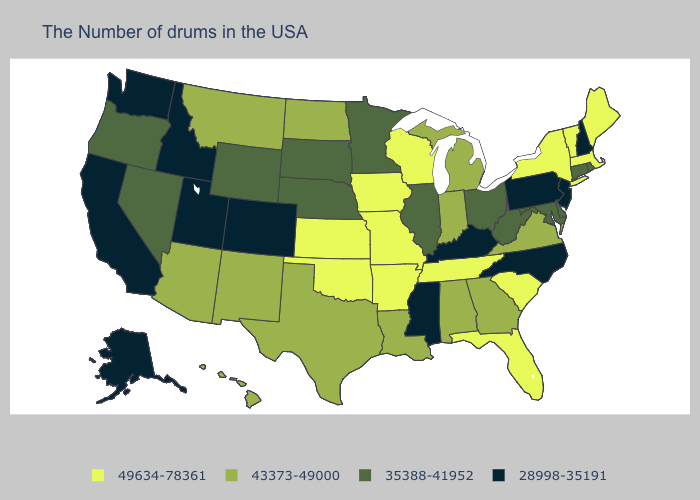Does Wyoming have a higher value than California?
Give a very brief answer. Yes. What is the lowest value in states that border Kansas?
Write a very short answer. 28998-35191. Is the legend a continuous bar?
Quick response, please. No. What is the highest value in the West ?
Give a very brief answer. 43373-49000. Among the states that border North Dakota , does Minnesota have the highest value?
Write a very short answer. No. What is the value of California?
Keep it brief. 28998-35191. Does Kentucky have the lowest value in the South?
Answer briefly. Yes. Which states have the lowest value in the MidWest?
Short answer required. Ohio, Illinois, Minnesota, Nebraska, South Dakota. Does Minnesota have the highest value in the MidWest?
Give a very brief answer. No. Name the states that have a value in the range 43373-49000?
Give a very brief answer. Virginia, Georgia, Michigan, Indiana, Alabama, Louisiana, Texas, North Dakota, New Mexico, Montana, Arizona, Hawaii. Name the states that have a value in the range 43373-49000?
Give a very brief answer. Virginia, Georgia, Michigan, Indiana, Alabama, Louisiana, Texas, North Dakota, New Mexico, Montana, Arizona, Hawaii. What is the value of Iowa?
Answer briefly. 49634-78361. What is the value of Ohio?
Answer briefly. 35388-41952. Does California have the lowest value in the West?
Be succinct. Yes. Is the legend a continuous bar?
Quick response, please. No. 